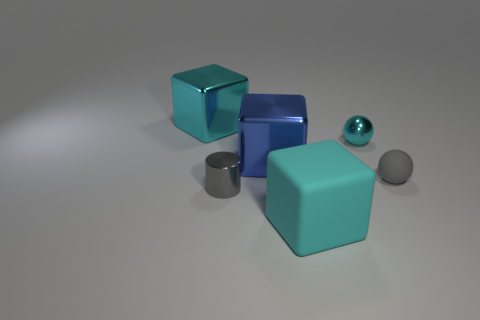Add 3 tiny red blocks. How many objects exist? 9 Subtract all large blue metal cubes. How many cubes are left? 2 Subtract 1 spheres. How many spheres are left? 1 Subtract all green spheres. How many yellow blocks are left? 0 Subtract all big blocks. Subtract all blue objects. How many objects are left? 2 Add 4 small matte balls. How many small matte balls are left? 5 Add 4 blocks. How many blocks exist? 7 Subtract all blue blocks. How many blocks are left? 2 Subtract 1 gray cylinders. How many objects are left? 5 Subtract all balls. How many objects are left? 4 